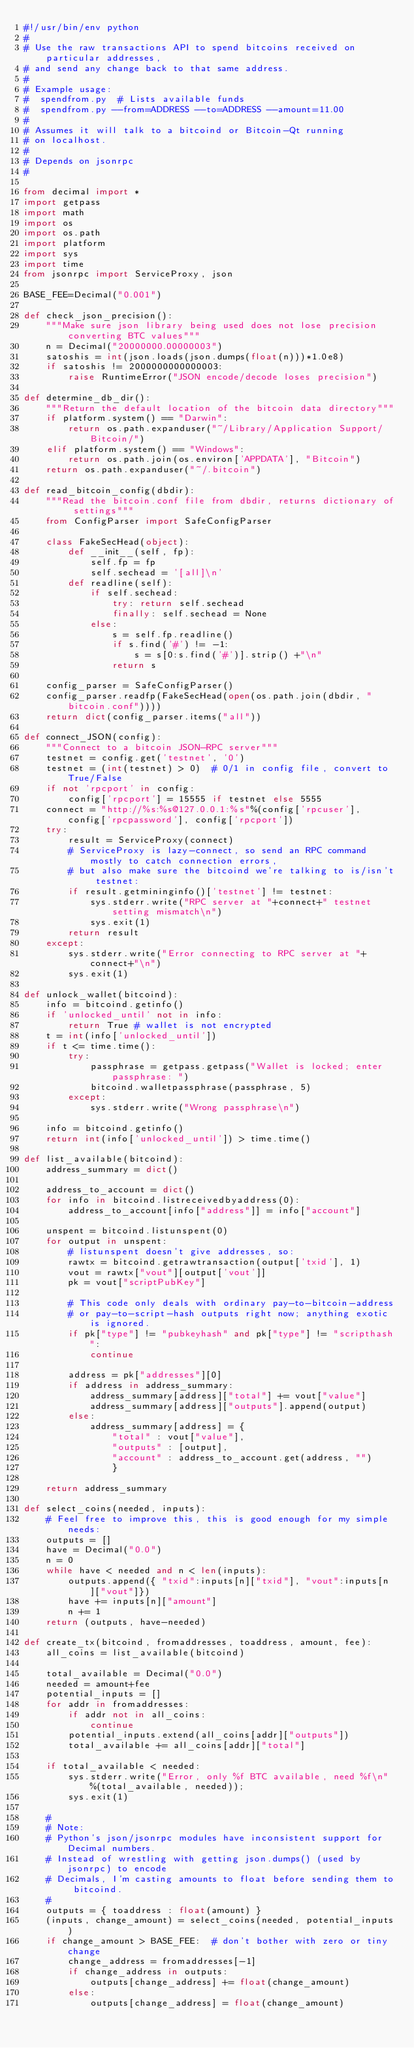Convert code to text. <code><loc_0><loc_0><loc_500><loc_500><_Python_>#!/usr/bin/env python
#
# Use the raw transactions API to spend bitcoins received on particular addresses,
# and send any change back to that same address.
#
# Example usage:
#  spendfrom.py  # Lists available funds
#  spendfrom.py --from=ADDRESS --to=ADDRESS --amount=11.00
#
# Assumes it will talk to a bitcoind or Bitcoin-Qt running
# on localhost.
#
# Depends on jsonrpc
#

from decimal import *
import getpass
import math
import os
import os.path
import platform
import sys
import time
from jsonrpc import ServiceProxy, json

BASE_FEE=Decimal("0.001")

def check_json_precision():
    """Make sure json library being used does not lose precision converting BTC values"""
    n = Decimal("20000000.00000003")
    satoshis = int(json.loads(json.dumps(float(n)))*1.0e8)
    if satoshis != 2000000000000003:
        raise RuntimeError("JSON encode/decode loses precision")

def determine_db_dir():
    """Return the default location of the bitcoin data directory"""
    if platform.system() == "Darwin":
        return os.path.expanduser("~/Library/Application Support/Bitcoin/")
    elif platform.system() == "Windows":
        return os.path.join(os.environ['APPDATA'], "Bitcoin")
    return os.path.expanduser("~/.bitcoin")

def read_bitcoin_config(dbdir):
    """Read the bitcoin.conf file from dbdir, returns dictionary of settings"""
    from ConfigParser import SafeConfigParser

    class FakeSecHead(object):
        def __init__(self, fp):
            self.fp = fp
            self.sechead = '[all]\n'
        def readline(self):
            if self.sechead:
                try: return self.sechead
                finally: self.sechead = None
            else:
                s = self.fp.readline()
                if s.find('#') != -1:
                    s = s[0:s.find('#')].strip() +"\n"
                return s

    config_parser = SafeConfigParser()
    config_parser.readfp(FakeSecHead(open(os.path.join(dbdir, "bitcoin.conf"))))
    return dict(config_parser.items("all"))

def connect_JSON(config):
    """Connect to a bitcoin JSON-RPC server"""
    testnet = config.get('testnet', '0')
    testnet = (int(testnet) > 0)  # 0/1 in config file, convert to True/False
    if not 'rpcport' in config:
        config['rpcport'] = 15555 if testnet else 5555
    connect = "http://%s:%s@127.0.0.1:%s"%(config['rpcuser'], config['rpcpassword'], config['rpcport'])
    try:
        result = ServiceProxy(connect)
        # ServiceProxy is lazy-connect, so send an RPC command mostly to catch connection errors,
        # but also make sure the bitcoind we're talking to is/isn't testnet:
        if result.getmininginfo()['testnet'] != testnet:
            sys.stderr.write("RPC server at "+connect+" testnet setting mismatch\n")
            sys.exit(1)
        return result
    except:
        sys.stderr.write("Error connecting to RPC server at "+connect+"\n")
        sys.exit(1)

def unlock_wallet(bitcoind):
    info = bitcoind.getinfo()
    if 'unlocked_until' not in info:
        return True # wallet is not encrypted
    t = int(info['unlocked_until'])
    if t <= time.time():
        try:
            passphrase = getpass.getpass("Wallet is locked; enter passphrase: ")
            bitcoind.walletpassphrase(passphrase, 5)
        except:
            sys.stderr.write("Wrong passphrase\n")

    info = bitcoind.getinfo()
    return int(info['unlocked_until']) > time.time()

def list_available(bitcoind):
    address_summary = dict()

    address_to_account = dict()
    for info in bitcoind.listreceivedbyaddress(0):
        address_to_account[info["address"]] = info["account"]

    unspent = bitcoind.listunspent(0)
    for output in unspent:
        # listunspent doesn't give addresses, so:
        rawtx = bitcoind.getrawtransaction(output['txid'], 1)
        vout = rawtx["vout"][output['vout']]
        pk = vout["scriptPubKey"]

        # This code only deals with ordinary pay-to-bitcoin-address
        # or pay-to-script-hash outputs right now; anything exotic is ignored.
        if pk["type"] != "pubkeyhash" and pk["type"] != "scripthash":
            continue
        
        address = pk["addresses"][0]
        if address in address_summary:
            address_summary[address]["total"] += vout["value"]
            address_summary[address]["outputs"].append(output)
        else:
            address_summary[address] = {
                "total" : vout["value"],
                "outputs" : [output],
                "account" : address_to_account.get(address, "")
                }

    return address_summary

def select_coins(needed, inputs):
    # Feel free to improve this, this is good enough for my simple needs:
    outputs = []
    have = Decimal("0.0")
    n = 0
    while have < needed and n < len(inputs):
        outputs.append({ "txid":inputs[n]["txid"], "vout":inputs[n]["vout"]})
        have += inputs[n]["amount"]
        n += 1
    return (outputs, have-needed)

def create_tx(bitcoind, fromaddresses, toaddress, amount, fee):
    all_coins = list_available(bitcoind)

    total_available = Decimal("0.0")
    needed = amount+fee
    potential_inputs = []
    for addr in fromaddresses:
        if addr not in all_coins:
            continue
        potential_inputs.extend(all_coins[addr]["outputs"])
        total_available += all_coins[addr]["total"]

    if total_available < needed:
        sys.stderr.write("Error, only %f BTC available, need %f\n"%(total_available, needed));
        sys.exit(1)

    #
    # Note:
    # Python's json/jsonrpc modules have inconsistent support for Decimal numbers.
    # Instead of wrestling with getting json.dumps() (used by jsonrpc) to encode
    # Decimals, I'm casting amounts to float before sending them to bitcoind.
    #  
    outputs = { toaddress : float(amount) }
    (inputs, change_amount) = select_coins(needed, potential_inputs)
    if change_amount > BASE_FEE:  # don't bother with zero or tiny change
        change_address = fromaddresses[-1]
        if change_address in outputs:
            outputs[change_address] += float(change_amount)
        else:
            outputs[change_address] = float(change_amount)
</code> 